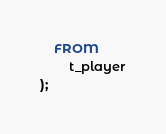<code> <loc_0><loc_0><loc_500><loc_500><_SQL_>    FROM 
        t_player
);</code> 